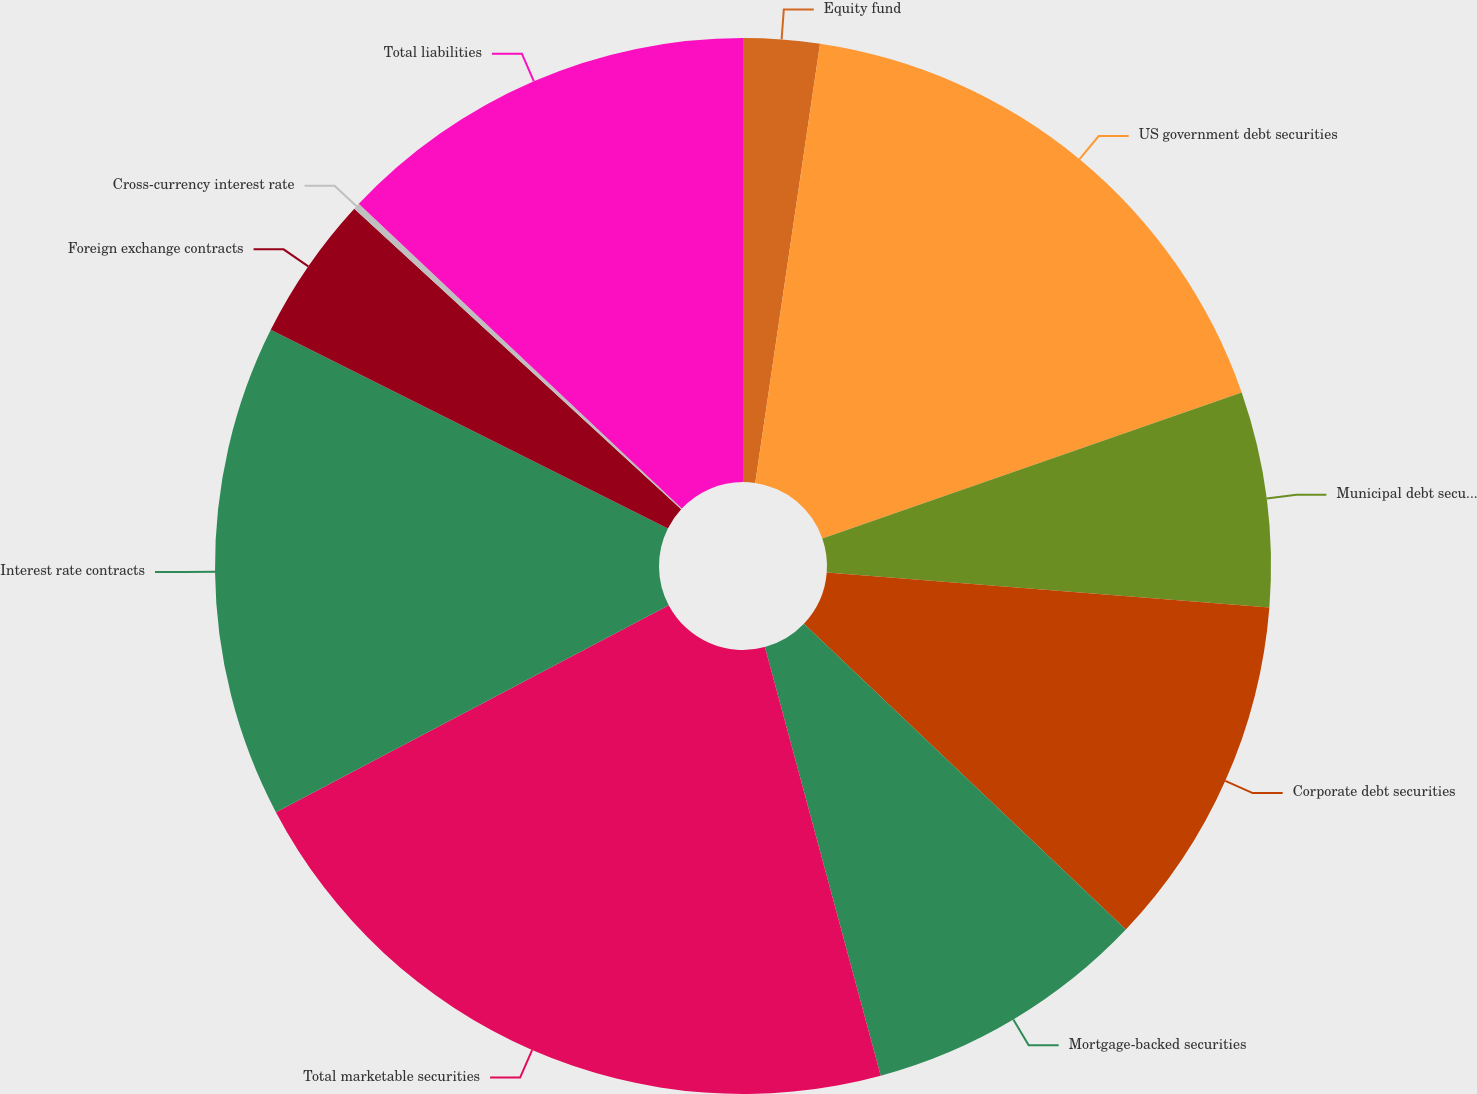Convert chart. <chart><loc_0><loc_0><loc_500><loc_500><pie_chart><fcel>Equity fund<fcel>US government debt securities<fcel>Municipal debt securities<fcel>Corporate debt securities<fcel>Mortgage-backed securities<fcel>Total marketable securities<fcel>Interest rate contracts<fcel>Foreign exchange contracts<fcel>Cross-currency interest rate<fcel>Total liabilities<nl><fcel>2.33%<fcel>17.34%<fcel>6.58%<fcel>10.84%<fcel>8.71%<fcel>21.48%<fcel>15.1%<fcel>4.45%<fcel>0.2%<fcel>12.97%<nl></chart> 